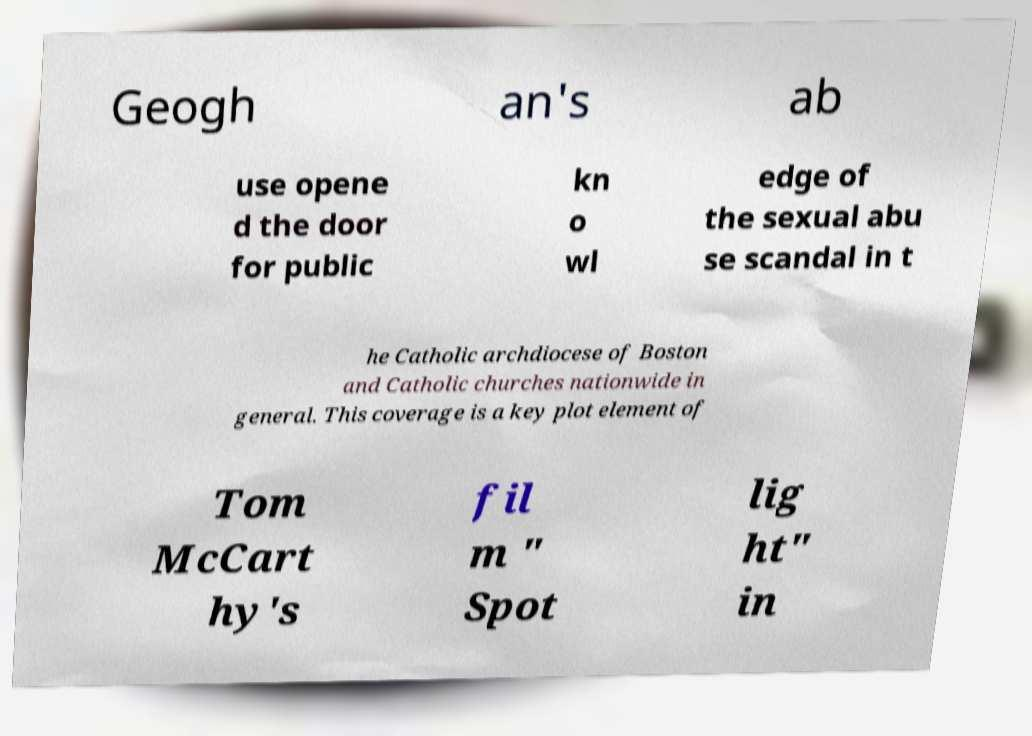What messages or text are displayed in this image? I need them in a readable, typed format. Geogh an's ab use opene d the door for public kn o wl edge of the sexual abu se scandal in t he Catholic archdiocese of Boston and Catholic churches nationwide in general. This coverage is a key plot element of Tom McCart hy's fil m " Spot lig ht" in 